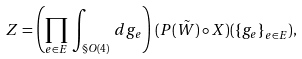Convert formula to latex. <formula><loc_0><loc_0><loc_500><loc_500>Z = \left ( \prod _ { e \in E } \, \int _ { \S O ( 4 ) } \, d g _ { e } \right ) \, ( P ( \tilde { W } ) \circ X ) ( { \{ g _ { e } \} } _ { e \in E } ) ,</formula> 